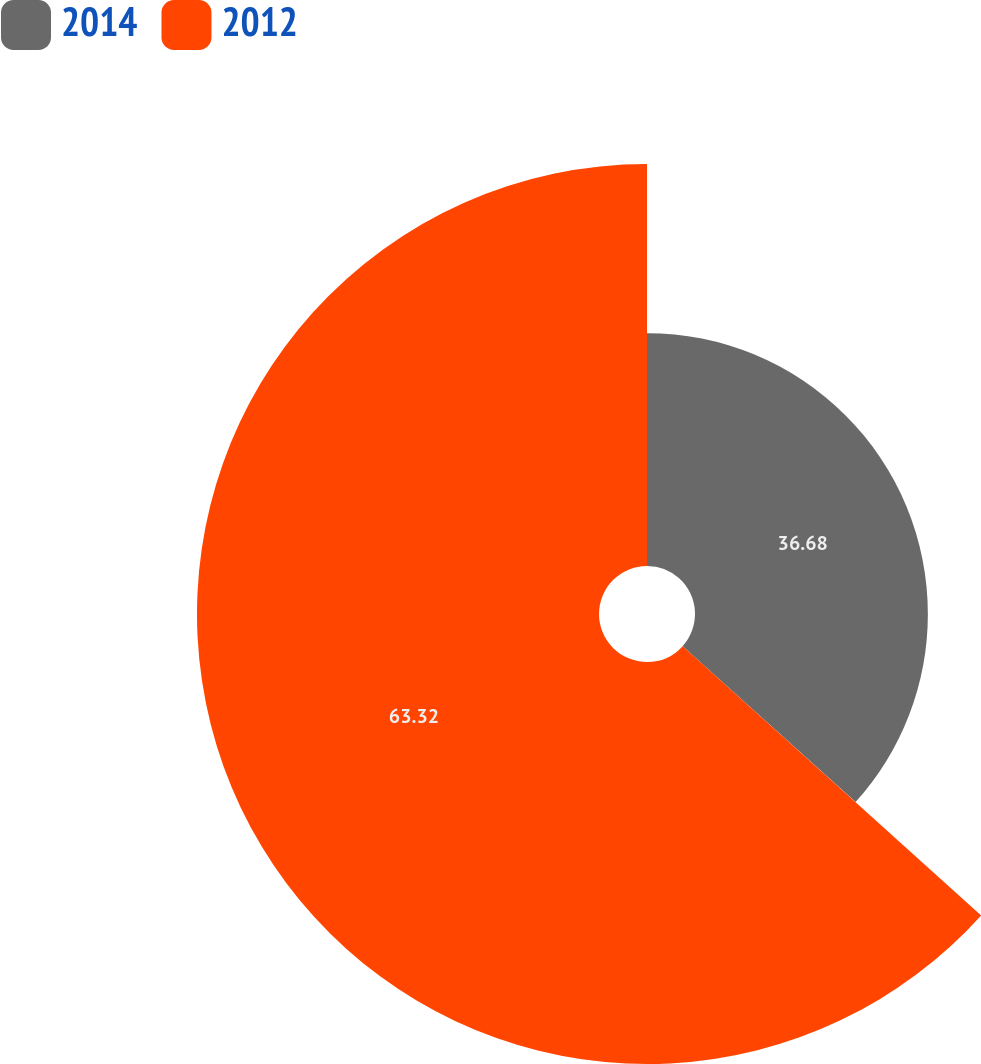Convert chart. <chart><loc_0><loc_0><loc_500><loc_500><pie_chart><fcel>2014<fcel>2012<nl><fcel>36.68%<fcel>63.32%<nl></chart> 